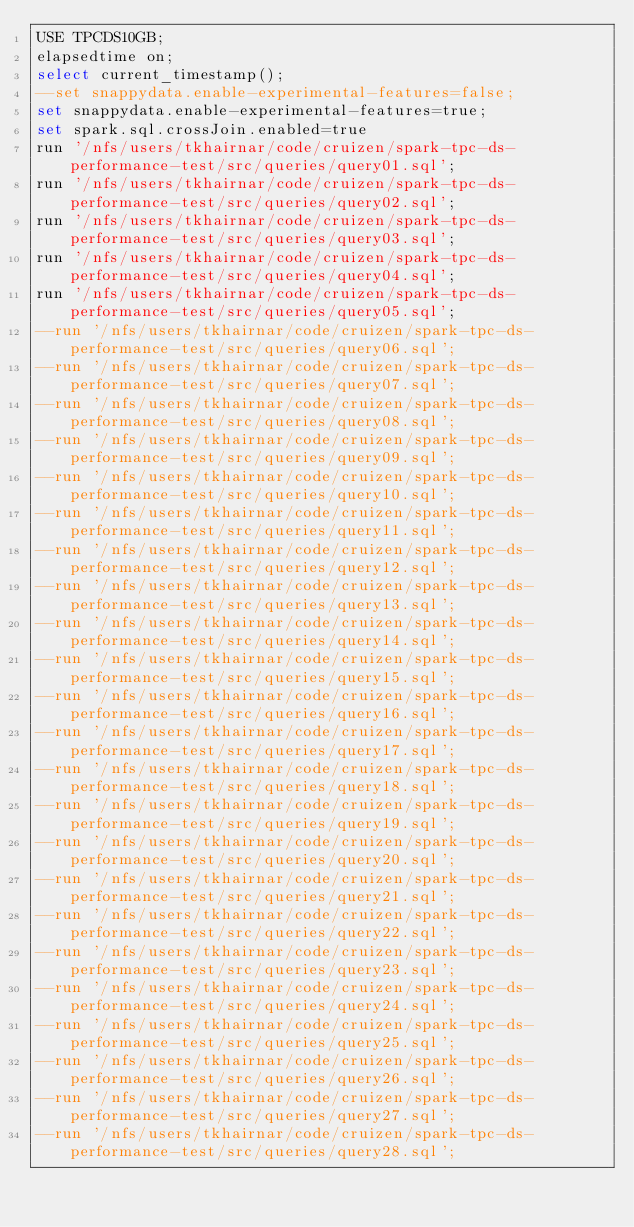Convert code to text. <code><loc_0><loc_0><loc_500><loc_500><_SQL_>USE TPCDS10GB;
elapsedtime on;
select current_timestamp();
--set snappydata.enable-experimental-features=false;
set snappydata.enable-experimental-features=true;
set spark.sql.crossJoin.enabled=true
run '/nfs/users/tkhairnar/code/cruizen/spark-tpc-ds-performance-test/src/queries/query01.sql';
run '/nfs/users/tkhairnar/code/cruizen/spark-tpc-ds-performance-test/src/queries/query02.sql';
run '/nfs/users/tkhairnar/code/cruizen/spark-tpc-ds-performance-test/src/queries/query03.sql';
run '/nfs/users/tkhairnar/code/cruizen/spark-tpc-ds-performance-test/src/queries/query04.sql';
run '/nfs/users/tkhairnar/code/cruizen/spark-tpc-ds-performance-test/src/queries/query05.sql';
--run '/nfs/users/tkhairnar/code/cruizen/spark-tpc-ds-performance-test/src/queries/query06.sql';
--run '/nfs/users/tkhairnar/code/cruizen/spark-tpc-ds-performance-test/src/queries/query07.sql';
--run '/nfs/users/tkhairnar/code/cruizen/spark-tpc-ds-performance-test/src/queries/query08.sql';
--run '/nfs/users/tkhairnar/code/cruizen/spark-tpc-ds-performance-test/src/queries/query09.sql';
--run '/nfs/users/tkhairnar/code/cruizen/spark-tpc-ds-performance-test/src/queries/query10.sql';
--run '/nfs/users/tkhairnar/code/cruizen/spark-tpc-ds-performance-test/src/queries/query11.sql';
--run '/nfs/users/tkhairnar/code/cruizen/spark-tpc-ds-performance-test/src/queries/query12.sql';
--run '/nfs/users/tkhairnar/code/cruizen/spark-tpc-ds-performance-test/src/queries/query13.sql';
--run '/nfs/users/tkhairnar/code/cruizen/spark-tpc-ds-performance-test/src/queries/query14.sql';
--run '/nfs/users/tkhairnar/code/cruizen/spark-tpc-ds-performance-test/src/queries/query15.sql';
--run '/nfs/users/tkhairnar/code/cruizen/spark-tpc-ds-performance-test/src/queries/query16.sql';
--run '/nfs/users/tkhairnar/code/cruizen/spark-tpc-ds-performance-test/src/queries/query17.sql';
--run '/nfs/users/tkhairnar/code/cruizen/spark-tpc-ds-performance-test/src/queries/query18.sql';
--run '/nfs/users/tkhairnar/code/cruizen/spark-tpc-ds-performance-test/src/queries/query19.sql';
--run '/nfs/users/tkhairnar/code/cruizen/spark-tpc-ds-performance-test/src/queries/query20.sql';
--run '/nfs/users/tkhairnar/code/cruizen/spark-tpc-ds-performance-test/src/queries/query21.sql';
--run '/nfs/users/tkhairnar/code/cruizen/spark-tpc-ds-performance-test/src/queries/query22.sql';
--run '/nfs/users/tkhairnar/code/cruizen/spark-tpc-ds-performance-test/src/queries/query23.sql';
--run '/nfs/users/tkhairnar/code/cruizen/spark-tpc-ds-performance-test/src/queries/query24.sql';
--run '/nfs/users/tkhairnar/code/cruizen/spark-tpc-ds-performance-test/src/queries/query25.sql';
--run '/nfs/users/tkhairnar/code/cruizen/spark-tpc-ds-performance-test/src/queries/query26.sql';
--run '/nfs/users/tkhairnar/code/cruizen/spark-tpc-ds-performance-test/src/queries/query27.sql';
--run '/nfs/users/tkhairnar/code/cruizen/spark-tpc-ds-performance-test/src/queries/query28.sql';</code> 